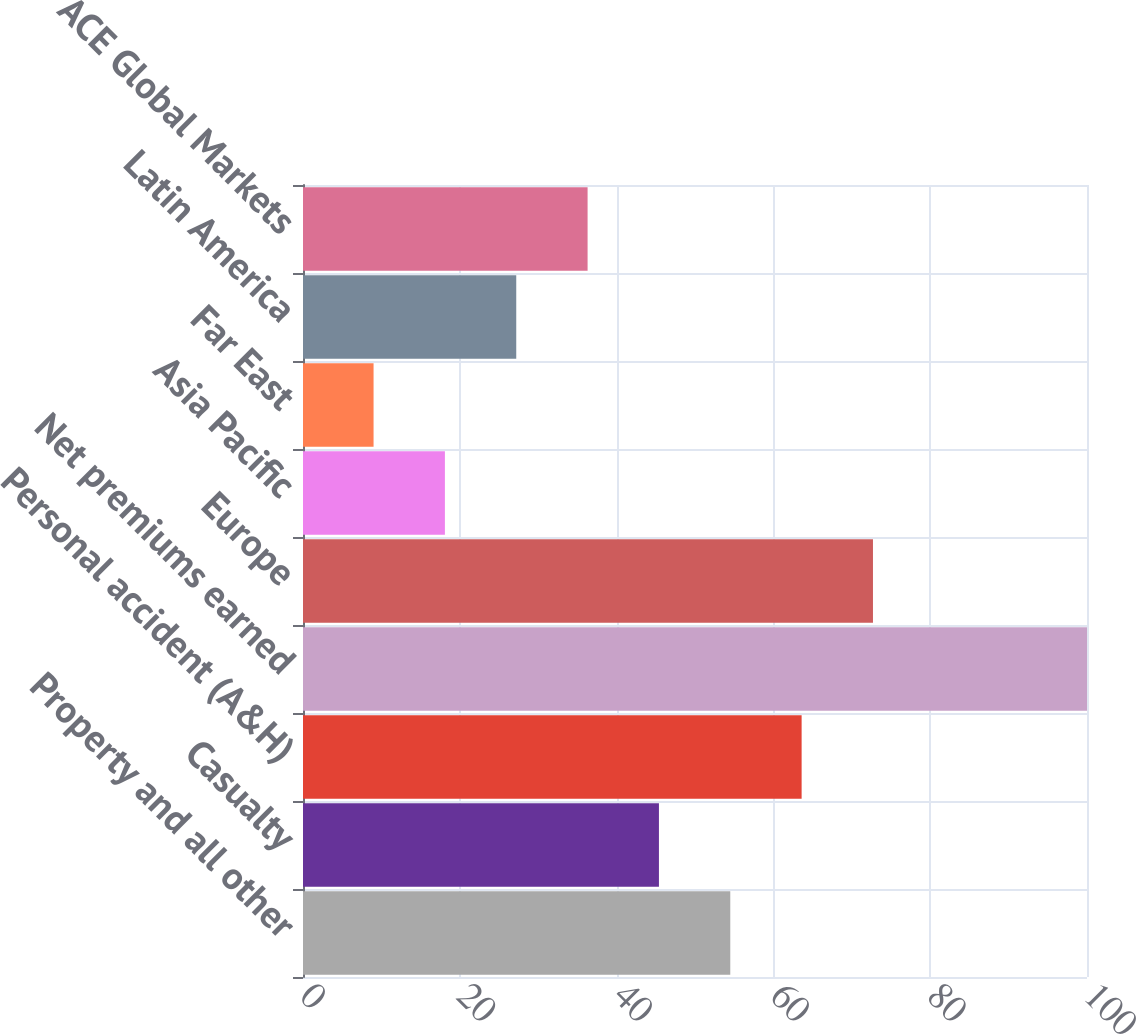Convert chart to OTSL. <chart><loc_0><loc_0><loc_500><loc_500><bar_chart><fcel>Property and all other<fcel>Casualty<fcel>Personal accident (A&H)<fcel>Net premiums earned<fcel>Europe<fcel>Asia Pacific<fcel>Far East<fcel>Latin America<fcel>ACE Global Markets<nl><fcel>54.5<fcel>45.4<fcel>63.6<fcel>100<fcel>72.7<fcel>18.1<fcel>9<fcel>27.2<fcel>36.3<nl></chart> 